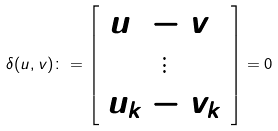Convert formula to latex. <formula><loc_0><loc_0><loc_500><loc_500>\delta ( u , v ) \colon = \left [ \begin{array} { c } u _ { 1 } - v _ { 1 } \\ \vdots \\ u _ { k } - v _ { k } \end{array} \right ] = 0</formula> 